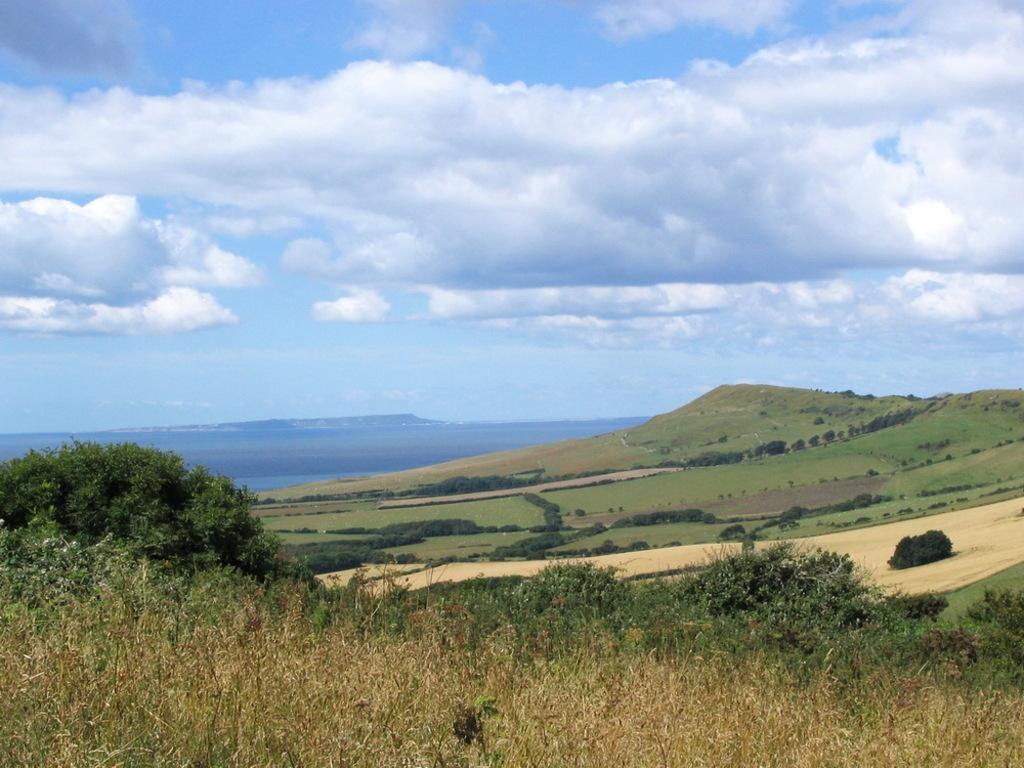What type of vegetation can be seen in the image? There are plants and trees in the image. Where is the hill located in the image? The hill is on the right side of the image. What can be seen in the sky in the image? There are clouds in the sky. What type of vessel is being exchanged between the owls in the image? There are no owls or vessels present in the image. 